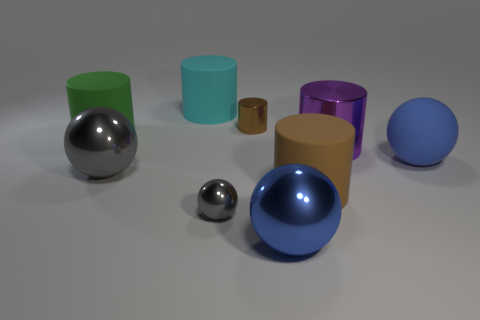What number of other things are there of the same size as the blue matte object?
Offer a very short reply. 6. Is there anything else that is the same shape as the big purple metal thing?
Provide a succinct answer. Yes. What is the color of the tiny shiny thing that is the same shape as the brown rubber thing?
Keep it short and to the point. Brown. The small cylinder that is made of the same material as the purple object is what color?
Provide a succinct answer. Brown. Are there an equal number of small gray metallic things left of the big brown matte cylinder and tiny brown things?
Provide a short and direct response. Yes. Do the ball that is right of the blue metal sphere and the cyan rubber cylinder have the same size?
Ensure brevity in your answer.  Yes. There is another metal cylinder that is the same size as the cyan cylinder; what is its color?
Keep it short and to the point. Purple. There is a blue object behind the blue sphere on the left side of the purple shiny cylinder; are there any brown metal things that are in front of it?
Offer a terse response. No. What is the ball left of the cyan matte cylinder made of?
Make the answer very short. Metal. Does the tiny gray metal object have the same shape as the big metallic thing that is on the left side of the large cyan rubber thing?
Ensure brevity in your answer.  Yes. 